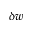<formula> <loc_0><loc_0><loc_500><loc_500>\delta w</formula> 